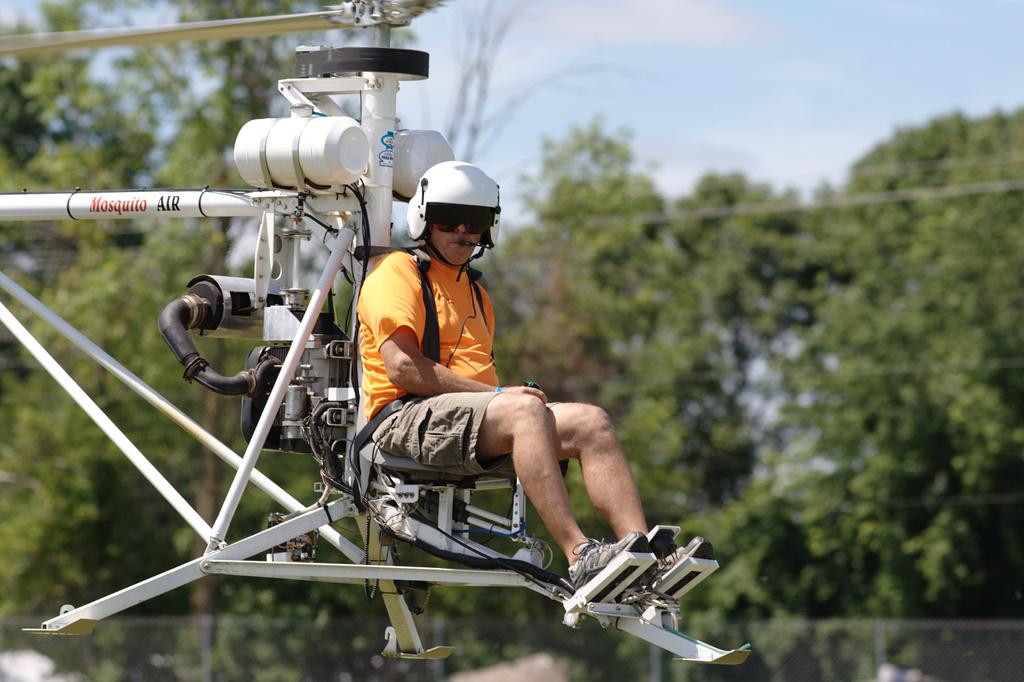What is the man in the image doing? The man is sitting on a seat in the image. What can be seen in the background of the image? The background of the image is blurry, but trees and the sky are visible. What is the main subject of the image? The main subject of the image is an aircraft. Where is the yak grazing in the image? There is no yak present in the image. What direction is the man facing in the image? The provided facts do not give information about the direction the man is facing, so we cannot definitively answer this question. 